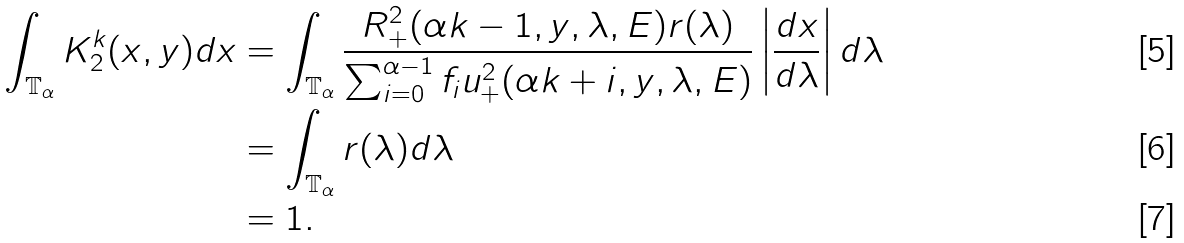Convert formula to latex. <formula><loc_0><loc_0><loc_500><loc_500>\int _ { \mathbb { T } _ { \alpha } } K _ { 2 } ^ { k } ( x , y ) d x & = \int _ { \mathbb { T } _ { \alpha } } \frac { R _ { + } ^ { 2 } ( \alpha k - 1 , y , \lambda , E ) r ( \lambda ) } { \sum _ { i = 0 } ^ { \alpha - 1 } f _ { i } u _ { + } ^ { 2 } ( \alpha k + i , y , \lambda , E ) } \left | \frac { d x } { d \lambda } \right | d \lambda \\ & = \int _ { \mathbb { T } _ { \alpha } } r ( \lambda ) d \lambda \\ & = 1 .</formula> 